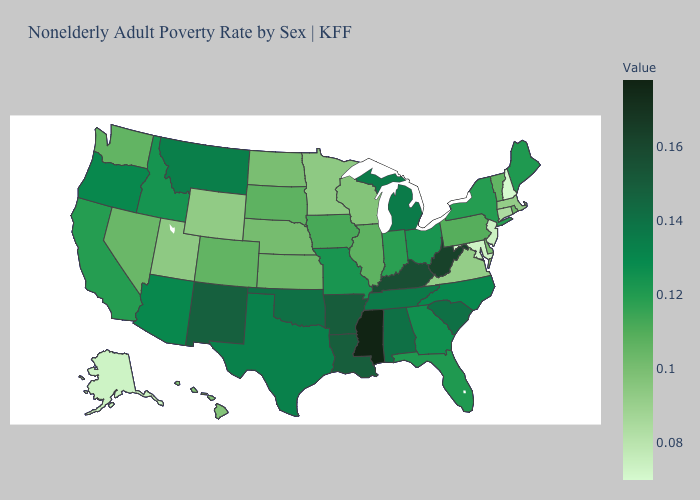Among the states that border Rhode Island , which have the lowest value?
Be succinct. Connecticut. Does Maine have the highest value in the Northeast?
Quick response, please. Yes. Does Idaho have the lowest value in the USA?
Keep it brief. No. Among the states that border South Dakota , which have the lowest value?
Give a very brief answer. Wyoming. 